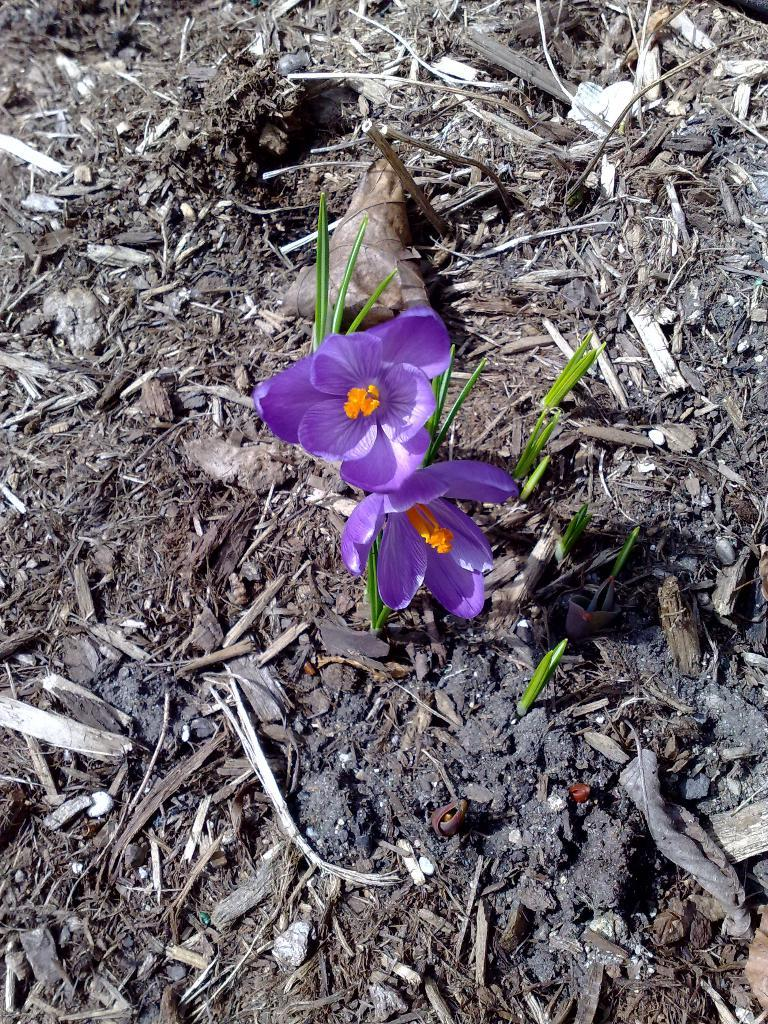How many flowers are in the image? There are two flowers in the image. What are the colors of the flowers? One flower is purple in color, and the other flower is pale orange in color. What else can be seen in the image besides the flowers? There are leaves and pieces of wood in the image. What type of jewel can be seen sparkling on the leaves in the image? There are no jewels present in the image; it features two flowers, leaves, and pieces of wood. How does the heat affect the growth of the flowers in the image? The image does not provide information about the temperature or heat, so it cannot be determined how it affects the flowers' growth. 